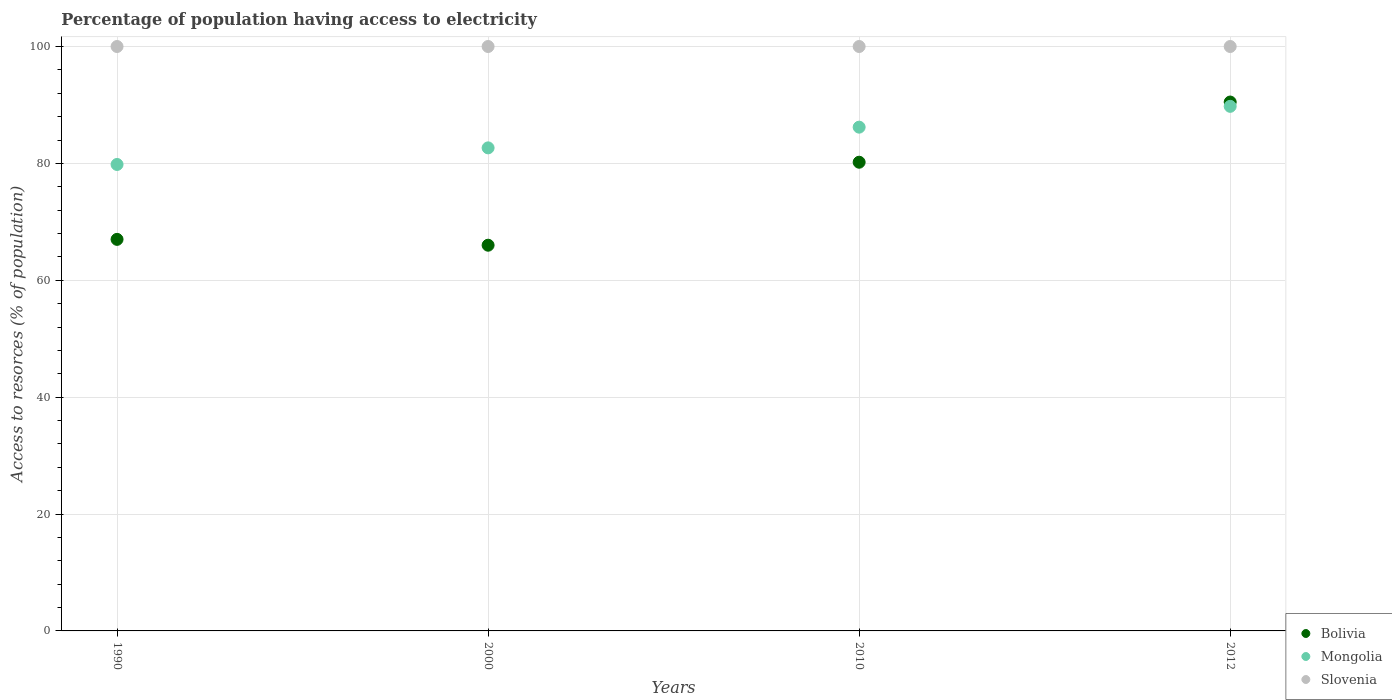How many different coloured dotlines are there?
Your answer should be compact. 3. Is the number of dotlines equal to the number of legend labels?
Offer a very short reply. Yes. Across all years, what is the maximum percentage of population having access to electricity in Bolivia?
Offer a terse response. 90.5. Across all years, what is the minimum percentage of population having access to electricity in Slovenia?
Offer a very short reply. 100. In which year was the percentage of population having access to electricity in Slovenia maximum?
Offer a terse response. 1990. What is the total percentage of population having access to electricity in Bolivia in the graph?
Keep it short and to the point. 303.7. What is the difference between the percentage of population having access to electricity in Bolivia in 1990 and the percentage of population having access to electricity in Mongolia in 2012?
Your answer should be compact. -22.76. What is the average percentage of population having access to electricity in Bolivia per year?
Offer a very short reply. 75.92. In how many years, is the percentage of population having access to electricity in Slovenia greater than 80 %?
Your response must be concise. 4. What is the ratio of the percentage of population having access to electricity in Mongolia in 1990 to that in 2012?
Your answer should be compact. 0.89. Is the percentage of population having access to electricity in Bolivia in 2010 less than that in 2012?
Your answer should be compact. Yes. What is the difference between the highest and the lowest percentage of population having access to electricity in Mongolia?
Give a very brief answer. 9.95. In how many years, is the percentage of population having access to electricity in Mongolia greater than the average percentage of population having access to electricity in Mongolia taken over all years?
Your answer should be compact. 2. Is the sum of the percentage of population having access to electricity in Mongolia in 2000 and 2010 greater than the maximum percentage of population having access to electricity in Slovenia across all years?
Give a very brief answer. Yes. Is the percentage of population having access to electricity in Bolivia strictly greater than the percentage of population having access to electricity in Mongolia over the years?
Ensure brevity in your answer.  No. Is the percentage of population having access to electricity in Slovenia strictly less than the percentage of population having access to electricity in Mongolia over the years?
Your response must be concise. No. How many dotlines are there?
Keep it short and to the point. 3. How many years are there in the graph?
Your answer should be compact. 4. What is the difference between two consecutive major ticks on the Y-axis?
Ensure brevity in your answer.  20. Are the values on the major ticks of Y-axis written in scientific E-notation?
Provide a short and direct response. No. Does the graph contain grids?
Offer a very short reply. Yes. What is the title of the graph?
Your response must be concise. Percentage of population having access to electricity. Does "Antigua and Barbuda" appear as one of the legend labels in the graph?
Provide a succinct answer. No. What is the label or title of the Y-axis?
Make the answer very short. Access to resorces (% of population). What is the Access to resorces (% of population) of Bolivia in 1990?
Make the answer very short. 67. What is the Access to resorces (% of population) of Mongolia in 1990?
Ensure brevity in your answer.  79.82. What is the Access to resorces (% of population) of Slovenia in 1990?
Offer a terse response. 100. What is the Access to resorces (% of population) of Bolivia in 2000?
Your response must be concise. 66. What is the Access to resorces (% of population) in Mongolia in 2000?
Ensure brevity in your answer.  82.66. What is the Access to resorces (% of population) of Slovenia in 2000?
Offer a very short reply. 100. What is the Access to resorces (% of population) in Bolivia in 2010?
Your answer should be compact. 80.2. What is the Access to resorces (% of population) of Mongolia in 2010?
Offer a very short reply. 86.2. What is the Access to resorces (% of population) of Bolivia in 2012?
Provide a succinct answer. 90.5. What is the Access to resorces (% of population) in Mongolia in 2012?
Offer a very short reply. 89.76. What is the Access to resorces (% of population) in Slovenia in 2012?
Offer a terse response. 100. Across all years, what is the maximum Access to resorces (% of population) in Bolivia?
Give a very brief answer. 90.5. Across all years, what is the maximum Access to resorces (% of population) of Mongolia?
Your response must be concise. 89.76. Across all years, what is the minimum Access to resorces (% of population) of Bolivia?
Provide a succinct answer. 66. Across all years, what is the minimum Access to resorces (% of population) of Mongolia?
Offer a terse response. 79.82. Across all years, what is the minimum Access to resorces (% of population) of Slovenia?
Ensure brevity in your answer.  100. What is the total Access to resorces (% of population) of Bolivia in the graph?
Give a very brief answer. 303.7. What is the total Access to resorces (% of population) of Mongolia in the graph?
Make the answer very short. 338.43. What is the total Access to resorces (% of population) of Slovenia in the graph?
Provide a succinct answer. 400. What is the difference between the Access to resorces (% of population) of Mongolia in 1990 and that in 2000?
Offer a very short reply. -2.84. What is the difference between the Access to resorces (% of population) of Slovenia in 1990 and that in 2000?
Your answer should be very brief. 0. What is the difference between the Access to resorces (% of population) of Mongolia in 1990 and that in 2010?
Your answer should be very brief. -6.38. What is the difference between the Access to resorces (% of population) in Bolivia in 1990 and that in 2012?
Provide a succinct answer. -23.5. What is the difference between the Access to resorces (% of population) in Mongolia in 1990 and that in 2012?
Ensure brevity in your answer.  -9.95. What is the difference between the Access to resorces (% of population) in Slovenia in 1990 and that in 2012?
Offer a very short reply. 0. What is the difference between the Access to resorces (% of population) of Bolivia in 2000 and that in 2010?
Keep it short and to the point. -14.2. What is the difference between the Access to resorces (% of population) in Mongolia in 2000 and that in 2010?
Offer a terse response. -3.54. What is the difference between the Access to resorces (% of population) in Bolivia in 2000 and that in 2012?
Offer a very short reply. -24.5. What is the difference between the Access to resorces (% of population) in Mongolia in 2000 and that in 2012?
Your answer should be compact. -7.11. What is the difference between the Access to resorces (% of population) of Mongolia in 2010 and that in 2012?
Ensure brevity in your answer.  -3.56. What is the difference between the Access to resorces (% of population) in Slovenia in 2010 and that in 2012?
Offer a terse response. 0. What is the difference between the Access to resorces (% of population) of Bolivia in 1990 and the Access to resorces (% of population) of Mongolia in 2000?
Provide a succinct answer. -15.66. What is the difference between the Access to resorces (% of population) of Bolivia in 1990 and the Access to resorces (% of population) of Slovenia in 2000?
Make the answer very short. -33. What is the difference between the Access to resorces (% of population) of Mongolia in 1990 and the Access to resorces (% of population) of Slovenia in 2000?
Ensure brevity in your answer.  -20.18. What is the difference between the Access to resorces (% of population) in Bolivia in 1990 and the Access to resorces (% of population) in Mongolia in 2010?
Give a very brief answer. -19.2. What is the difference between the Access to resorces (% of population) of Bolivia in 1990 and the Access to resorces (% of population) of Slovenia in 2010?
Give a very brief answer. -33. What is the difference between the Access to resorces (% of population) of Mongolia in 1990 and the Access to resorces (% of population) of Slovenia in 2010?
Keep it short and to the point. -20.18. What is the difference between the Access to resorces (% of population) of Bolivia in 1990 and the Access to resorces (% of population) of Mongolia in 2012?
Ensure brevity in your answer.  -22.76. What is the difference between the Access to resorces (% of population) in Bolivia in 1990 and the Access to resorces (% of population) in Slovenia in 2012?
Make the answer very short. -33. What is the difference between the Access to resorces (% of population) of Mongolia in 1990 and the Access to resorces (% of population) of Slovenia in 2012?
Your answer should be compact. -20.18. What is the difference between the Access to resorces (% of population) of Bolivia in 2000 and the Access to resorces (% of population) of Mongolia in 2010?
Make the answer very short. -20.2. What is the difference between the Access to resorces (% of population) in Bolivia in 2000 and the Access to resorces (% of population) in Slovenia in 2010?
Keep it short and to the point. -34. What is the difference between the Access to resorces (% of population) in Mongolia in 2000 and the Access to resorces (% of population) in Slovenia in 2010?
Give a very brief answer. -17.34. What is the difference between the Access to resorces (% of population) in Bolivia in 2000 and the Access to resorces (% of population) in Mongolia in 2012?
Your answer should be compact. -23.76. What is the difference between the Access to resorces (% of population) of Bolivia in 2000 and the Access to resorces (% of population) of Slovenia in 2012?
Your response must be concise. -34. What is the difference between the Access to resorces (% of population) in Mongolia in 2000 and the Access to resorces (% of population) in Slovenia in 2012?
Your answer should be compact. -17.34. What is the difference between the Access to resorces (% of population) of Bolivia in 2010 and the Access to resorces (% of population) of Mongolia in 2012?
Provide a short and direct response. -9.56. What is the difference between the Access to resorces (% of population) in Bolivia in 2010 and the Access to resorces (% of population) in Slovenia in 2012?
Your answer should be very brief. -19.8. What is the difference between the Access to resorces (% of population) of Mongolia in 2010 and the Access to resorces (% of population) of Slovenia in 2012?
Offer a terse response. -13.8. What is the average Access to resorces (% of population) of Bolivia per year?
Offer a very short reply. 75.92. What is the average Access to resorces (% of population) in Mongolia per year?
Provide a succinct answer. 84.61. In the year 1990, what is the difference between the Access to resorces (% of population) of Bolivia and Access to resorces (% of population) of Mongolia?
Offer a very short reply. -12.82. In the year 1990, what is the difference between the Access to resorces (% of population) in Bolivia and Access to resorces (% of population) in Slovenia?
Offer a very short reply. -33. In the year 1990, what is the difference between the Access to resorces (% of population) of Mongolia and Access to resorces (% of population) of Slovenia?
Your answer should be compact. -20.18. In the year 2000, what is the difference between the Access to resorces (% of population) in Bolivia and Access to resorces (% of population) in Mongolia?
Your answer should be very brief. -16.66. In the year 2000, what is the difference between the Access to resorces (% of population) in Bolivia and Access to resorces (% of population) in Slovenia?
Your response must be concise. -34. In the year 2000, what is the difference between the Access to resorces (% of population) of Mongolia and Access to resorces (% of population) of Slovenia?
Ensure brevity in your answer.  -17.34. In the year 2010, what is the difference between the Access to resorces (% of population) in Bolivia and Access to resorces (% of population) in Mongolia?
Your answer should be very brief. -6. In the year 2010, what is the difference between the Access to resorces (% of population) of Bolivia and Access to resorces (% of population) of Slovenia?
Offer a terse response. -19.8. In the year 2012, what is the difference between the Access to resorces (% of population) of Bolivia and Access to resorces (% of population) of Mongolia?
Your response must be concise. 0.74. In the year 2012, what is the difference between the Access to resorces (% of population) in Mongolia and Access to resorces (% of population) in Slovenia?
Your answer should be very brief. -10.24. What is the ratio of the Access to resorces (% of population) in Bolivia in 1990 to that in 2000?
Offer a very short reply. 1.02. What is the ratio of the Access to resorces (% of population) of Mongolia in 1990 to that in 2000?
Offer a terse response. 0.97. What is the ratio of the Access to resorces (% of population) in Slovenia in 1990 to that in 2000?
Offer a very short reply. 1. What is the ratio of the Access to resorces (% of population) in Bolivia in 1990 to that in 2010?
Keep it short and to the point. 0.84. What is the ratio of the Access to resorces (% of population) of Mongolia in 1990 to that in 2010?
Your answer should be very brief. 0.93. What is the ratio of the Access to resorces (% of population) of Slovenia in 1990 to that in 2010?
Ensure brevity in your answer.  1. What is the ratio of the Access to resorces (% of population) in Bolivia in 1990 to that in 2012?
Offer a very short reply. 0.74. What is the ratio of the Access to resorces (% of population) in Mongolia in 1990 to that in 2012?
Your response must be concise. 0.89. What is the ratio of the Access to resorces (% of population) of Bolivia in 2000 to that in 2010?
Offer a terse response. 0.82. What is the ratio of the Access to resorces (% of population) of Mongolia in 2000 to that in 2010?
Provide a succinct answer. 0.96. What is the ratio of the Access to resorces (% of population) in Slovenia in 2000 to that in 2010?
Provide a short and direct response. 1. What is the ratio of the Access to resorces (% of population) of Bolivia in 2000 to that in 2012?
Offer a terse response. 0.73. What is the ratio of the Access to resorces (% of population) of Mongolia in 2000 to that in 2012?
Your answer should be very brief. 0.92. What is the ratio of the Access to resorces (% of population) of Bolivia in 2010 to that in 2012?
Your answer should be compact. 0.89. What is the ratio of the Access to resorces (% of population) of Mongolia in 2010 to that in 2012?
Provide a succinct answer. 0.96. What is the ratio of the Access to resorces (% of population) in Slovenia in 2010 to that in 2012?
Provide a short and direct response. 1. What is the difference between the highest and the second highest Access to resorces (% of population) of Mongolia?
Your answer should be compact. 3.56. What is the difference between the highest and the second highest Access to resorces (% of population) in Slovenia?
Offer a terse response. 0. What is the difference between the highest and the lowest Access to resorces (% of population) of Mongolia?
Your answer should be compact. 9.95. 